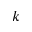<formula> <loc_0><loc_0><loc_500><loc_500>k</formula> 